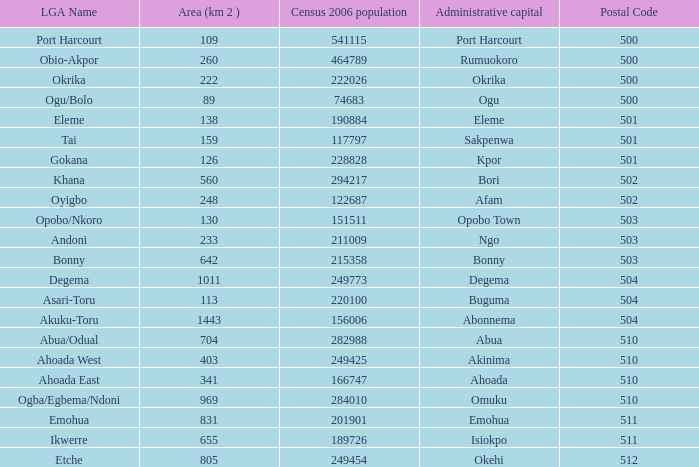What is the 2006 census population when the area is 159? 1.0. 